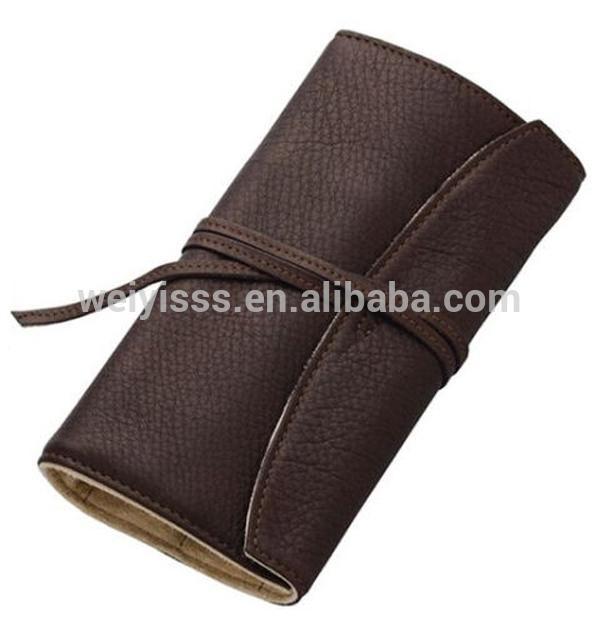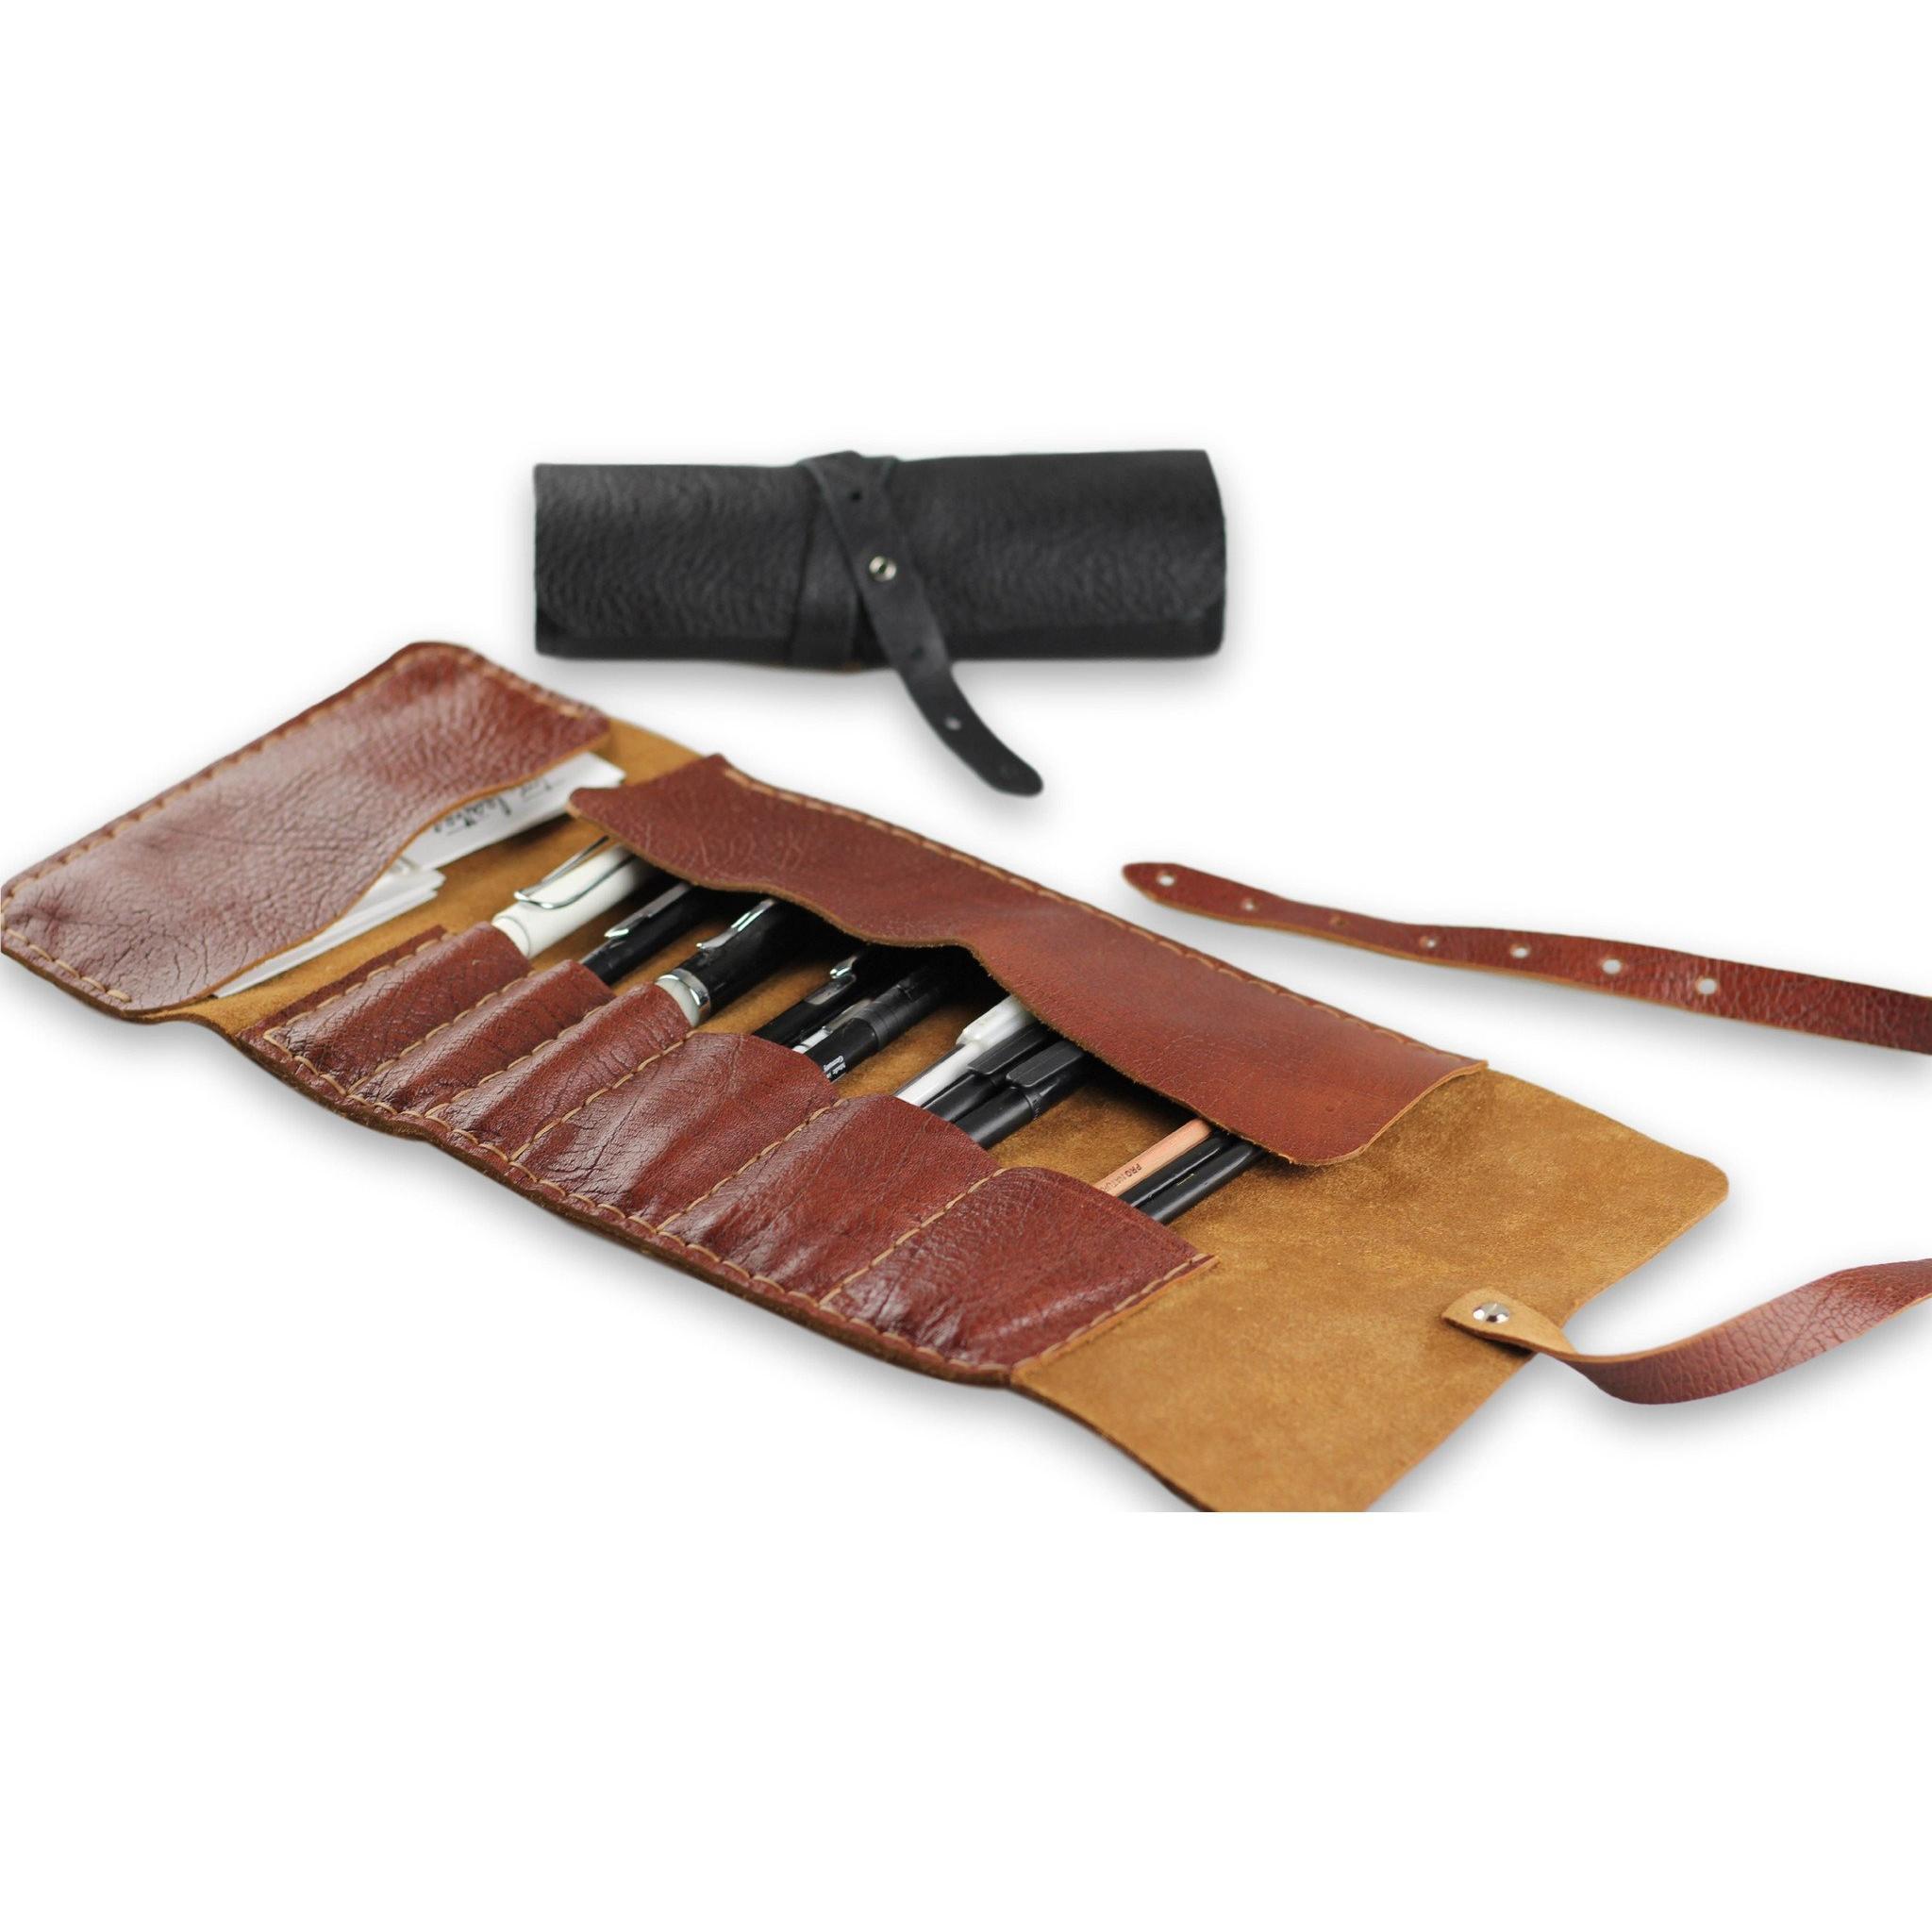The first image is the image on the left, the second image is the image on the right. For the images shown, is this caption "One image includes an opened pink case filled with writing implements." true? Answer yes or no. No. The first image is the image on the left, the second image is the image on the right. Examine the images to the left and right. Is the description "Two pink pencil cases sit next to each other in the image on the right." accurate? Answer yes or no. No. 